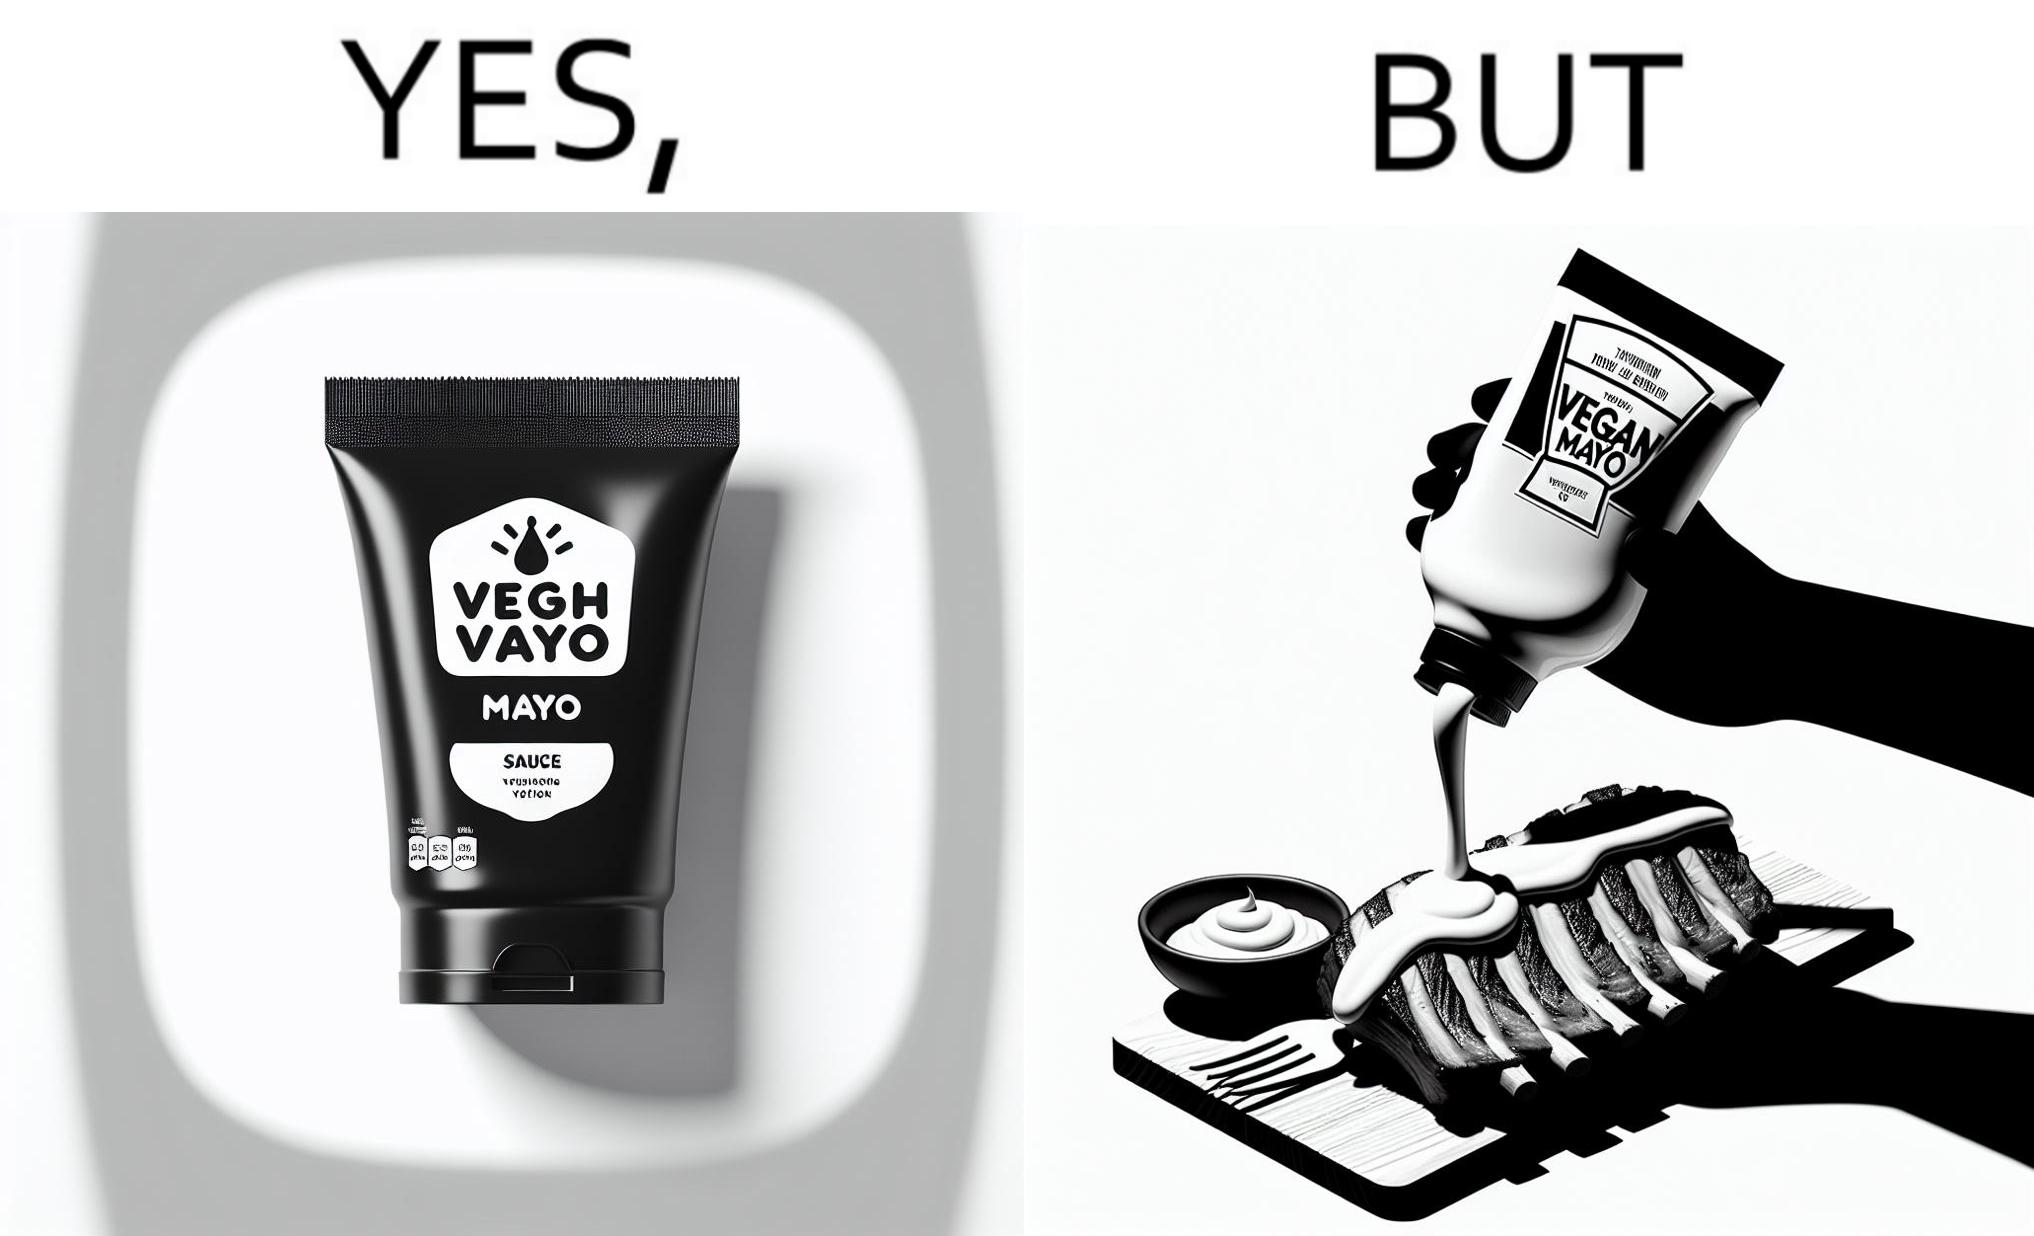Describe what you see in this image. The image is ironical, as vegan mayo sauce is being poured on rib steak, which is non-vegetarian. The person might as well just use normal mayo sauce instead. 